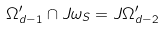<formula> <loc_0><loc_0><loc_500><loc_500>\Omega _ { d - 1 } ^ { \prime } \cap J \omega _ { S } = J \Omega _ { d - 2 } ^ { \prime }</formula> 